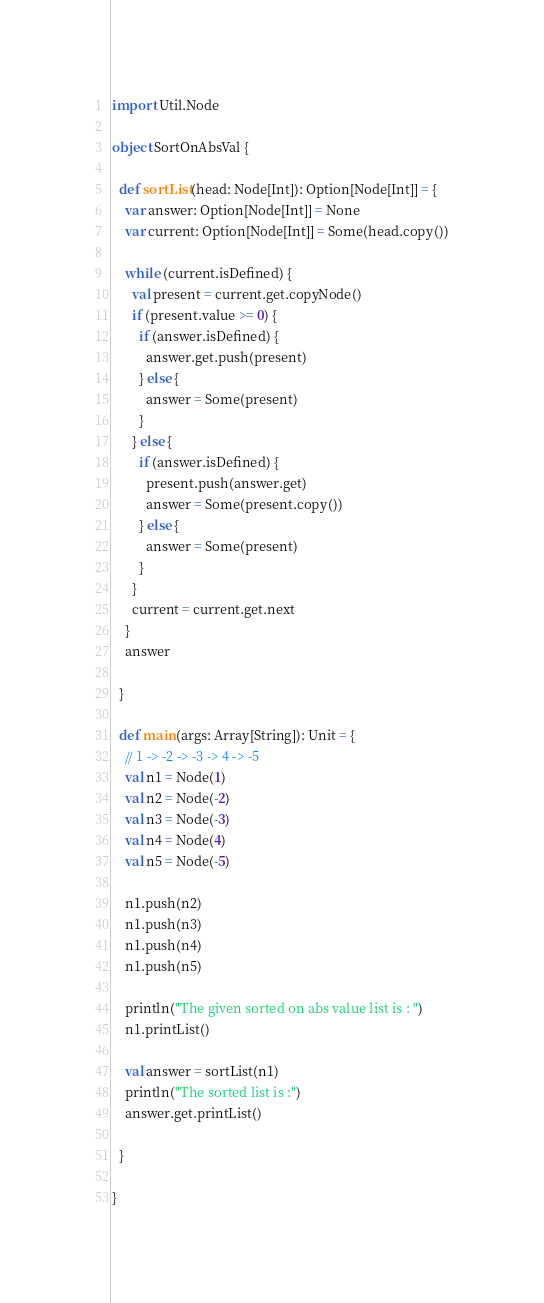<code> <loc_0><loc_0><loc_500><loc_500><_Scala_>import Util.Node

object SortOnAbsVal {

  def sortList(head: Node[Int]): Option[Node[Int]] = {
    var answer: Option[Node[Int]] = None
    var current: Option[Node[Int]] = Some(head.copy())

    while (current.isDefined) {
      val present = current.get.copyNode()
      if (present.value >= 0) {
        if (answer.isDefined) {
          answer.get.push(present)
        } else {
          answer = Some(present)
        }
      } else {
        if (answer.isDefined) {
          present.push(answer.get)
          answer = Some(present.copy())
        } else {
          answer = Some(present)
        }
      }
      current = current.get.next
    }
    answer

  }

  def main(args: Array[String]): Unit = {
    // 1 -> -2 -> -3 -> 4 -> -5
    val n1 = Node(1)
    val n2 = Node(-2)
    val n3 = Node(-3)
    val n4 = Node(4)
    val n5 = Node(-5)

    n1.push(n2)
    n1.push(n3)
    n1.push(n4)
    n1.push(n5)

    println("The given sorted on abs value list is : ")
    n1.printList()

    val answer = sortList(n1)
    println("The sorted list is :")
    answer.get.printList()

  }

}
</code> 